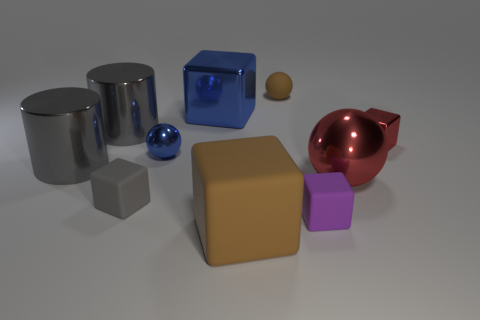What's the texture of the objects in front of the red apple-like object? The objects in front of the red, apple-like figure have a matte finish, namely the tan cube and the small purple cube, which contrast with the shinier objects in the image. What shapes are present in the image? The image contains a variety of geometric shapes: cylinders, spheres, and cubes, showcasing a mix of curves and edges. 